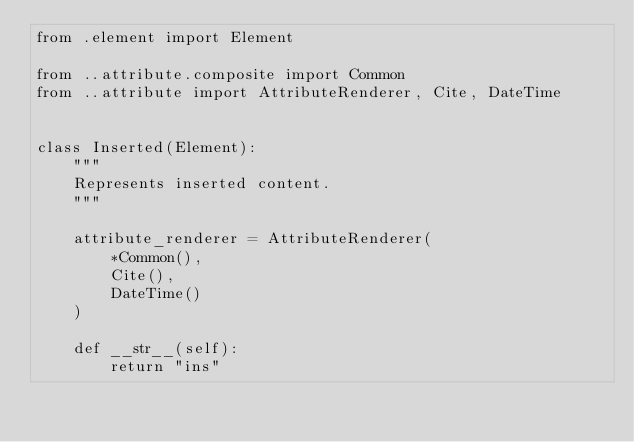Convert code to text. <code><loc_0><loc_0><loc_500><loc_500><_Python_>from .element import Element

from ..attribute.composite import Common
from ..attribute import AttributeRenderer, Cite, DateTime


class Inserted(Element):
    """
    Represents inserted content.
    """

    attribute_renderer = AttributeRenderer(
        *Common(),
        Cite(),
        DateTime()
    )

    def __str__(self):
        return "ins"
</code> 